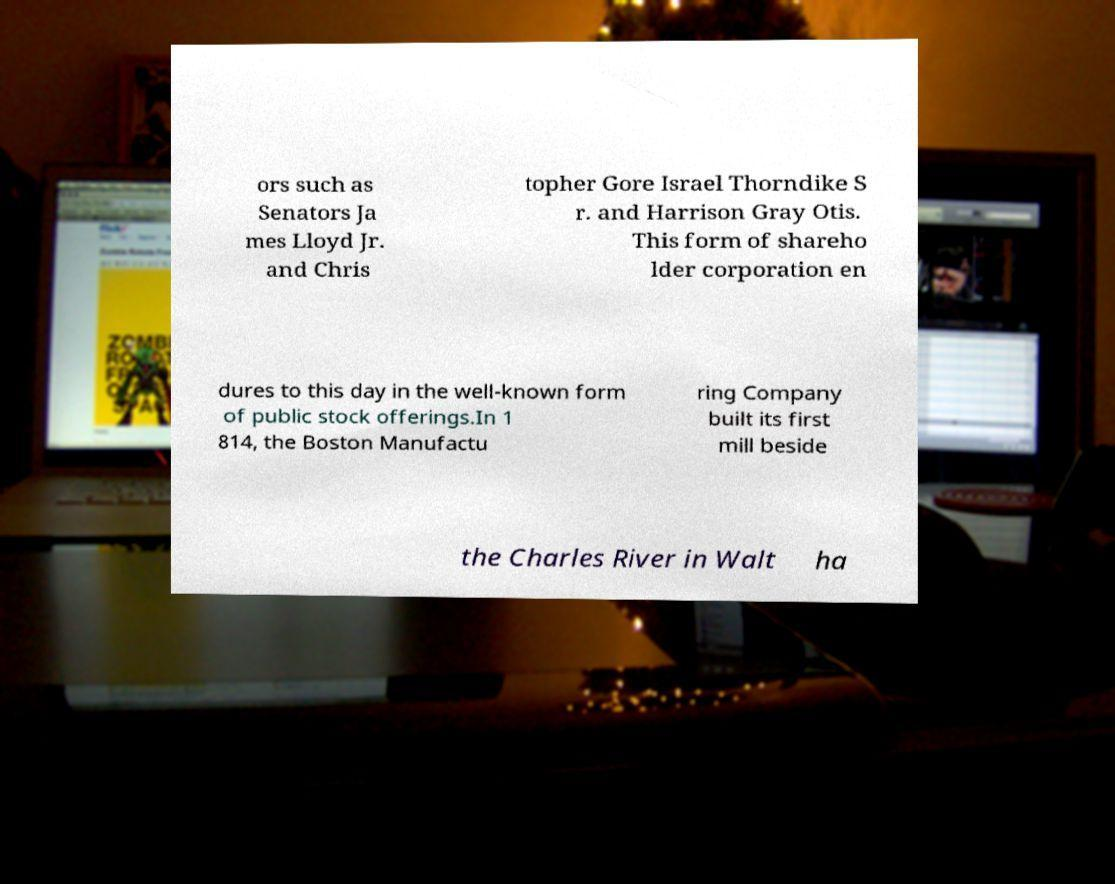Please identify and transcribe the text found in this image. ors such as Senators Ja mes Lloyd Jr. and Chris topher Gore Israel Thorndike S r. and Harrison Gray Otis. This form of shareho lder corporation en dures to this day in the well-known form of public stock offerings.In 1 814, the Boston Manufactu ring Company built its first mill beside the Charles River in Walt ha 